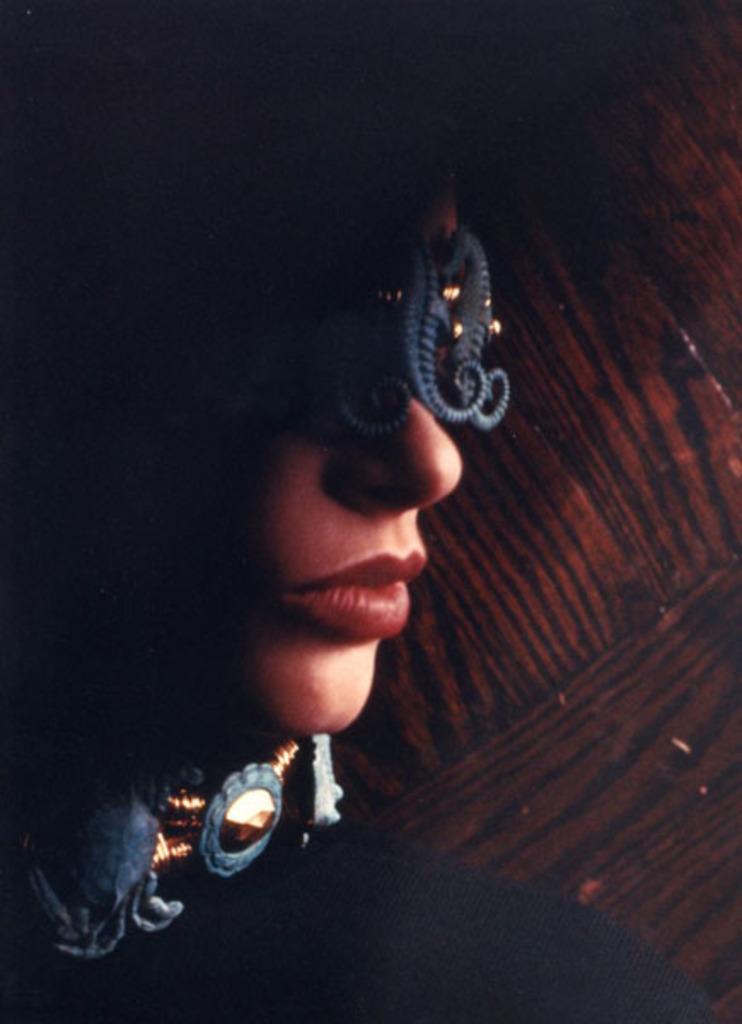In one or two sentences, can you explain what this image depicts? In this image we can see a woman lips in red color. Background it is in brown color. 